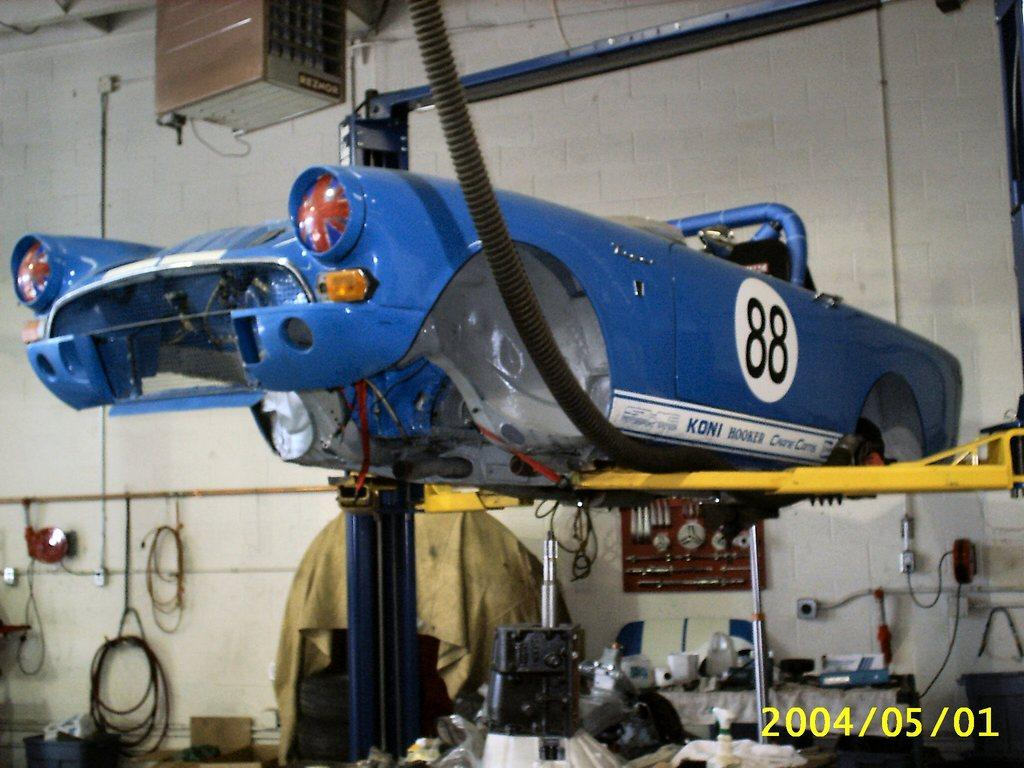Provide a one-sentence caption for the provided image. An old racing car with a KONI sticker on the side is in a service center. 